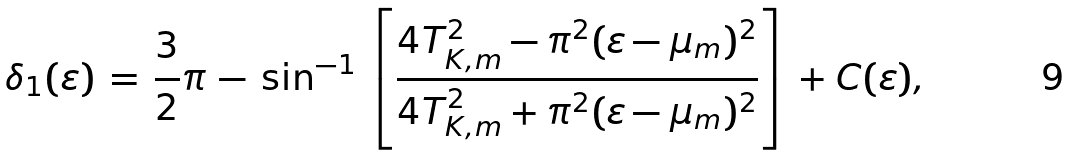Convert formula to latex. <formula><loc_0><loc_0><loc_500><loc_500>\delta _ { 1 } ( \varepsilon ) \, = \, \frac { 3 } { 2 } \pi \, - \, \sin ^ { - 1 } \, \left [ \frac { 4 T _ { K , m } ^ { 2 } - \pi ^ { 2 } ( \varepsilon - \mu _ { m } ) ^ { 2 } } { 4 T _ { K , m } ^ { 2 } + \pi ^ { 2 } ( \varepsilon - \mu _ { m } ) ^ { 2 } } \right ] \, + C ( \varepsilon ) ,</formula> 